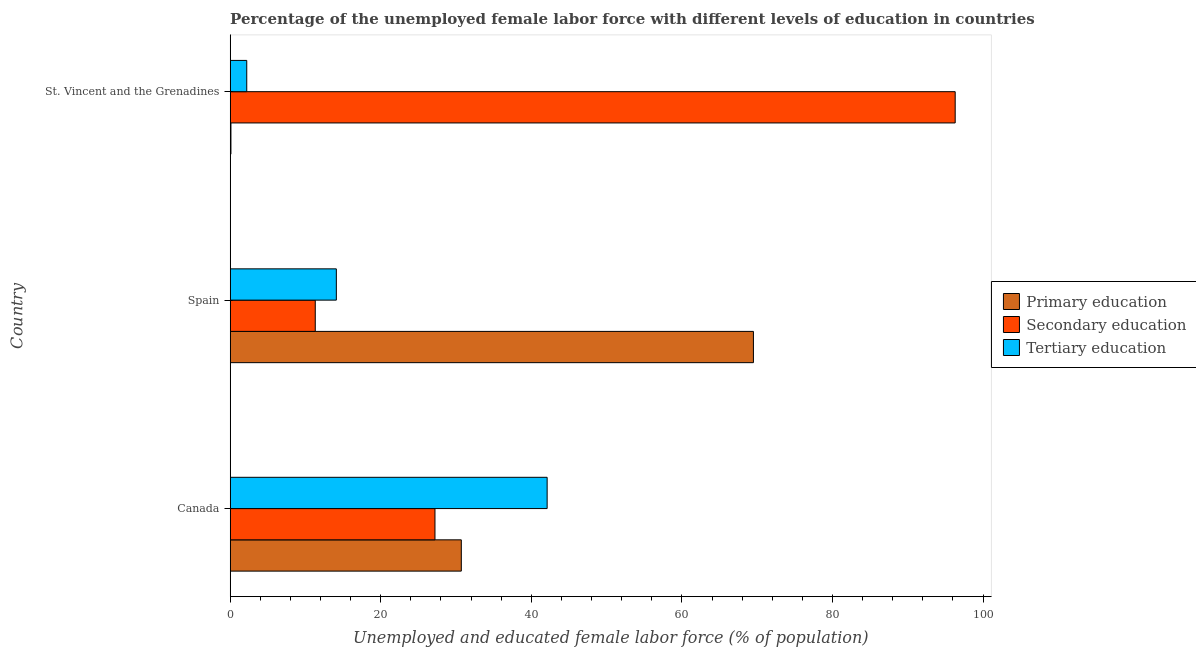How many groups of bars are there?
Provide a short and direct response. 3. How many bars are there on the 1st tick from the bottom?
Keep it short and to the point. 3. What is the label of the 2nd group of bars from the top?
Give a very brief answer. Spain. In how many cases, is the number of bars for a given country not equal to the number of legend labels?
Provide a short and direct response. 0. What is the percentage of female labor force who received secondary education in St. Vincent and the Grenadines?
Provide a succinct answer. 96.3. Across all countries, what is the maximum percentage of female labor force who received secondary education?
Offer a terse response. 96.3. Across all countries, what is the minimum percentage of female labor force who received primary education?
Offer a terse response. 0.1. In which country was the percentage of female labor force who received tertiary education maximum?
Make the answer very short. Canada. In which country was the percentage of female labor force who received tertiary education minimum?
Your answer should be very brief. St. Vincent and the Grenadines. What is the total percentage of female labor force who received tertiary education in the graph?
Give a very brief answer. 58.4. What is the difference between the percentage of female labor force who received secondary education in Spain and that in St. Vincent and the Grenadines?
Your answer should be compact. -85. What is the difference between the percentage of female labor force who received tertiary education in Canada and the percentage of female labor force who received secondary education in Spain?
Keep it short and to the point. 30.8. What is the average percentage of female labor force who received secondary education per country?
Offer a terse response. 44.93. What is the difference between the percentage of female labor force who received primary education and percentage of female labor force who received tertiary education in Spain?
Ensure brevity in your answer.  55.4. What is the ratio of the percentage of female labor force who received tertiary education in Spain to that in St. Vincent and the Grenadines?
Ensure brevity in your answer.  6.41. Is the percentage of female labor force who received primary education in Canada less than that in Spain?
Make the answer very short. Yes. Is the difference between the percentage of female labor force who received secondary education in Canada and Spain greater than the difference between the percentage of female labor force who received primary education in Canada and Spain?
Keep it short and to the point. Yes. What is the difference between the highest and the second highest percentage of female labor force who received secondary education?
Make the answer very short. 69.1. What is the difference between the highest and the lowest percentage of female labor force who received primary education?
Your response must be concise. 69.4. What does the 3rd bar from the top in St. Vincent and the Grenadines represents?
Your answer should be compact. Primary education. What does the 2nd bar from the bottom in Spain represents?
Offer a terse response. Secondary education. Are all the bars in the graph horizontal?
Provide a short and direct response. Yes. What is the difference between two consecutive major ticks on the X-axis?
Offer a very short reply. 20. Are the values on the major ticks of X-axis written in scientific E-notation?
Make the answer very short. No. Does the graph contain any zero values?
Ensure brevity in your answer.  No. Does the graph contain grids?
Make the answer very short. No. Where does the legend appear in the graph?
Provide a short and direct response. Center right. How are the legend labels stacked?
Offer a very short reply. Vertical. What is the title of the graph?
Provide a succinct answer. Percentage of the unemployed female labor force with different levels of education in countries. What is the label or title of the X-axis?
Your response must be concise. Unemployed and educated female labor force (% of population). What is the label or title of the Y-axis?
Offer a very short reply. Country. What is the Unemployed and educated female labor force (% of population) of Primary education in Canada?
Ensure brevity in your answer.  30.7. What is the Unemployed and educated female labor force (% of population) in Secondary education in Canada?
Offer a terse response. 27.2. What is the Unemployed and educated female labor force (% of population) of Tertiary education in Canada?
Ensure brevity in your answer.  42.1. What is the Unemployed and educated female labor force (% of population) in Primary education in Spain?
Your answer should be very brief. 69.5. What is the Unemployed and educated female labor force (% of population) of Secondary education in Spain?
Keep it short and to the point. 11.3. What is the Unemployed and educated female labor force (% of population) in Tertiary education in Spain?
Keep it short and to the point. 14.1. What is the Unemployed and educated female labor force (% of population) of Primary education in St. Vincent and the Grenadines?
Your answer should be very brief. 0.1. What is the Unemployed and educated female labor force (% of population) of Secondary education in St. Vincent and the Grenadines?
Your response must be concise. 96.3. What is the Unemployed and educated female labor force (% of population) of Tertiary education in St. Vincent and the Grenadines?
Offer a very short reply. 2.2. Across all countries, what is the maximum Unemployed and educated female labor force (% of population) of Primary education?
Provide a short and direct response. 69.5. Across all countries, what is the maximum Unemployed and educated female labor force (% of population) in Secondary education?
Provide a succinct answer. 96.3. Across all countries, what is the maximum Unemployed and educated female labor force (% of population) of Tertiary education?
Your response must be concise. 42.1. Across all countries, what is the minimum Unemployed and educated female labor force (% of population) in Primary education?
Your answer should be very brief. 0.1. Across all countries, what is the minimum Unemployed and educated female labor force (% of population) in Secondary education?
Keep it short and to the point. 11.3. Across all countries, what is the minimum Unemployed and educated female labor force (% of population) of Tertiary education?
Your answer should be very brief. 2.2. What is the total Unemployed and educated female labor force (% of population) of Primary education in the graph?
Provide a succinct answer. 100.3. What is the total Unemployed and educated female labor force (% of population) of Secondary education in the graph?
Provide a short and direct response. 134.8. What is the total Unemployed and educated female labor force (% of population) in Tertiary education in the graph?
Your answer should be very brief. 58.4. What is the difference between the Unemployed and educated female labor force (% of population) of Primary education in Canada and that in Spain?
Ensure brevity in your answer.  -38.8. What is the difference between the Unemployed and educated female labor force (% of population) of Primary education in Canada and that in St. Vincent and the Grenadines?
Your answer should be compact. 30.6. What is the difference between the Unemployed and educated female labor force (% of population) in Secondary education in Canada and that in St. Vincent and the Grenadines?
Offer a terse response. -69.1. What is the difference between the Unemployed and educated female labor force (% of population) in Tertiary education in Canada and that in St. Vincent and the Grenadines?
Offer a very short reply. 39.9. What is the difference between the Unemployed and educated female labor force (% of population) in Primary education in Spain and that in St. Vincent and the Grenadines?
Your response must be concise. 69.4. What is the difference between the Unemployed and educated female labor force (% of population) of Secondary education in Spain and that in St. Vincent and the Grenadines?
Offer a terse response. -85. What is the difference between the Unemployed and educated female labor force (% of population) in Tertiary education in Spain and that in St. Vincent and the Grenadines?
Offer a terse response. 11.9. What is the difference between the Unemployed and educated female labor force (% of population) in Primary education in Canada and the Unemployed and educated female labor force (% of population) in Secondary education in Spain?
Ensure brevity in your answer.  19.4. What is the difference between the Unemployed and educated female labor force (% of population) in Primary education in Canada and the Unemployed and educated female labor force (% of population) in Tertiary education in Spain?
Offer a terse response. 16.6. What is the difference between the Unemployed and educated female labor force (% of population) of Primary education in Canada and the Unemployed and educated female labor force (% of population) of Secondary education in St. Vincent and the Grenadines?
Provide a succinct answer. -65.6. What is the difference between the Unemployed and educated female labor force (% of population) in Secondary education in Canada and the Unemployed and educated female labor force (% of population) in Tertiary education in St. Vincent and the Grenadines?
Offer a very short reply. 25. What is the difference between the Unemployed and educated female labor force (% of population) in Primary education in Spain and the Unemployed and educated female labor force (% of population) in Secondary education in St. Vincent and the Grenadines?
Offer a very short reply. -26.8. What is the difference between the Unemployed and educated female labor force (% of population) of Primary education in Spain and the Unemployed and educated female labor force (% of population) of Tertiary education in St. Vincent and the Grenadines?
Make the answer very short. 67.3. What is the difference between the Unemployed and educated female labor force (% of population) of Secondary education in Spain and the Unemployed and educated female labor force (% of population) of Tertiary education in St. Vincent and the Grenadines?
Your answer should be very brief. 9.1. What is the average Unemployed and educated female labor force (% of population) in Primary education per country?
Offer a very short reply. 33.43. What is the average Unemployed and educated female labor force (% of population) of Secondary education per country?
Your answer should be very brief. 44.93. What is the average Unemployed and educated female labor force (% of population) of Tertiary education per country?
Provide a short and direct response. 19.47. What is the difference between the Unemployed and educated female labor force (% of population) in Secondary education and Unemployed and educated female labor force (% of population) in Tertiary education in Canada?
Provide a short and direct response. -14.9. What is the difference between the Unemployed and educated female labor force (% of population) of Primary education and Unemployed and educated female labor force (% of population) of Secondary education in Spain?
Offer a terse response. 58.2. What is the difference between the Unemployed and educated female labor force (% of population) in Primary education and Unemployed and educated female labor force (% of population) in Tertiary education in Spain?
Provide a short and direct response. 55.4. What is the difference between the Unemployed and educated female labor force (% of population) of Primary education and Unemployed and educated female labor force (% of population) of Secondary education in St. Vincent and the Grenadines?
Offer a terse response. -96.2. What is the difference between the Unemployed and educated female labor force (% of population) in Secondary education and Unemployed and educated female labor force (% of population) in Tertiary education in St. Vincent and the Grenadines?
Make the answer very short. 94.1. What is the ratio of the Unemployed and educated female labor force (% of population) in Primary education in Canada to that in Spain?
Your answer should be very brief. 0.44. What is the ratio of the Unemployed and educated female labor force (% of population) of Secondary education in Canada to that in Spain?
Offer a very short reply. 2.41. What is the ratio of the Unemployed and educated female labor force (% of population) in Tertiary education in Canada to that in Spain?
Provide a succinct answer. 2.99. What is the ratio of the Unemployed and educated female labor force (% of population) of Primary education in Canada to that in St. Vincent and the Grenadines?
Your response must be concise. 307. What is the ratio of the Unemployed and educated female labor force (% of population) of Secondary education in Canada to that in St. Vincent and the Grenadines?
Ensure brevity in your answer.  0.28. What is the ratio of the Unemployed and educated female labor force (% of population) in Tertiary education in Canada to that in St. Vincent and the Grenadines?
Give a very brief answer. 19.14. What is the ratio of the Unemployed and educated female labor force (% of population) of Primary education in Spain to that in St. Vincent and the Grenadines?
Provide a succinct answer. 695. What is the ratio of the Unemployed and educated female labor force (% of population) of Secondary education in Spain to that in St. Vincent and the Grenadines?
Provide a succinct answer. 0.12. What is the ratio of the Unemployed and educated female labor force (% of population) of Tertiary education in Spain to that in St. Vincent and the Grenadines?
Provide a succinct answer. 6.41. What is the difference between the highest and the second highest Unemployed and educated female labor force (% of population) of Primary education?
Your answer should be very brief. 38.8. What is the difference between the highest and the second highest Unemployed and educated female labor force (% of population) of Secondary education?
Provide a short and direct response. 69.1. What is the difference between the highest and the lowest Unemployed and educated female labor force (% of population) in Primary education?
Keep it short and to the point. 69.4. What is the difference between the highest and the lowest Unemployed and educated female labor force (% of population) in Secondary education?
Offer a terse response. 85. What is the difference between the highest and the lowest Unemployed and educated female labor force (% of population) of Tertiary education?
Your answer should be very brief. 39.9. 